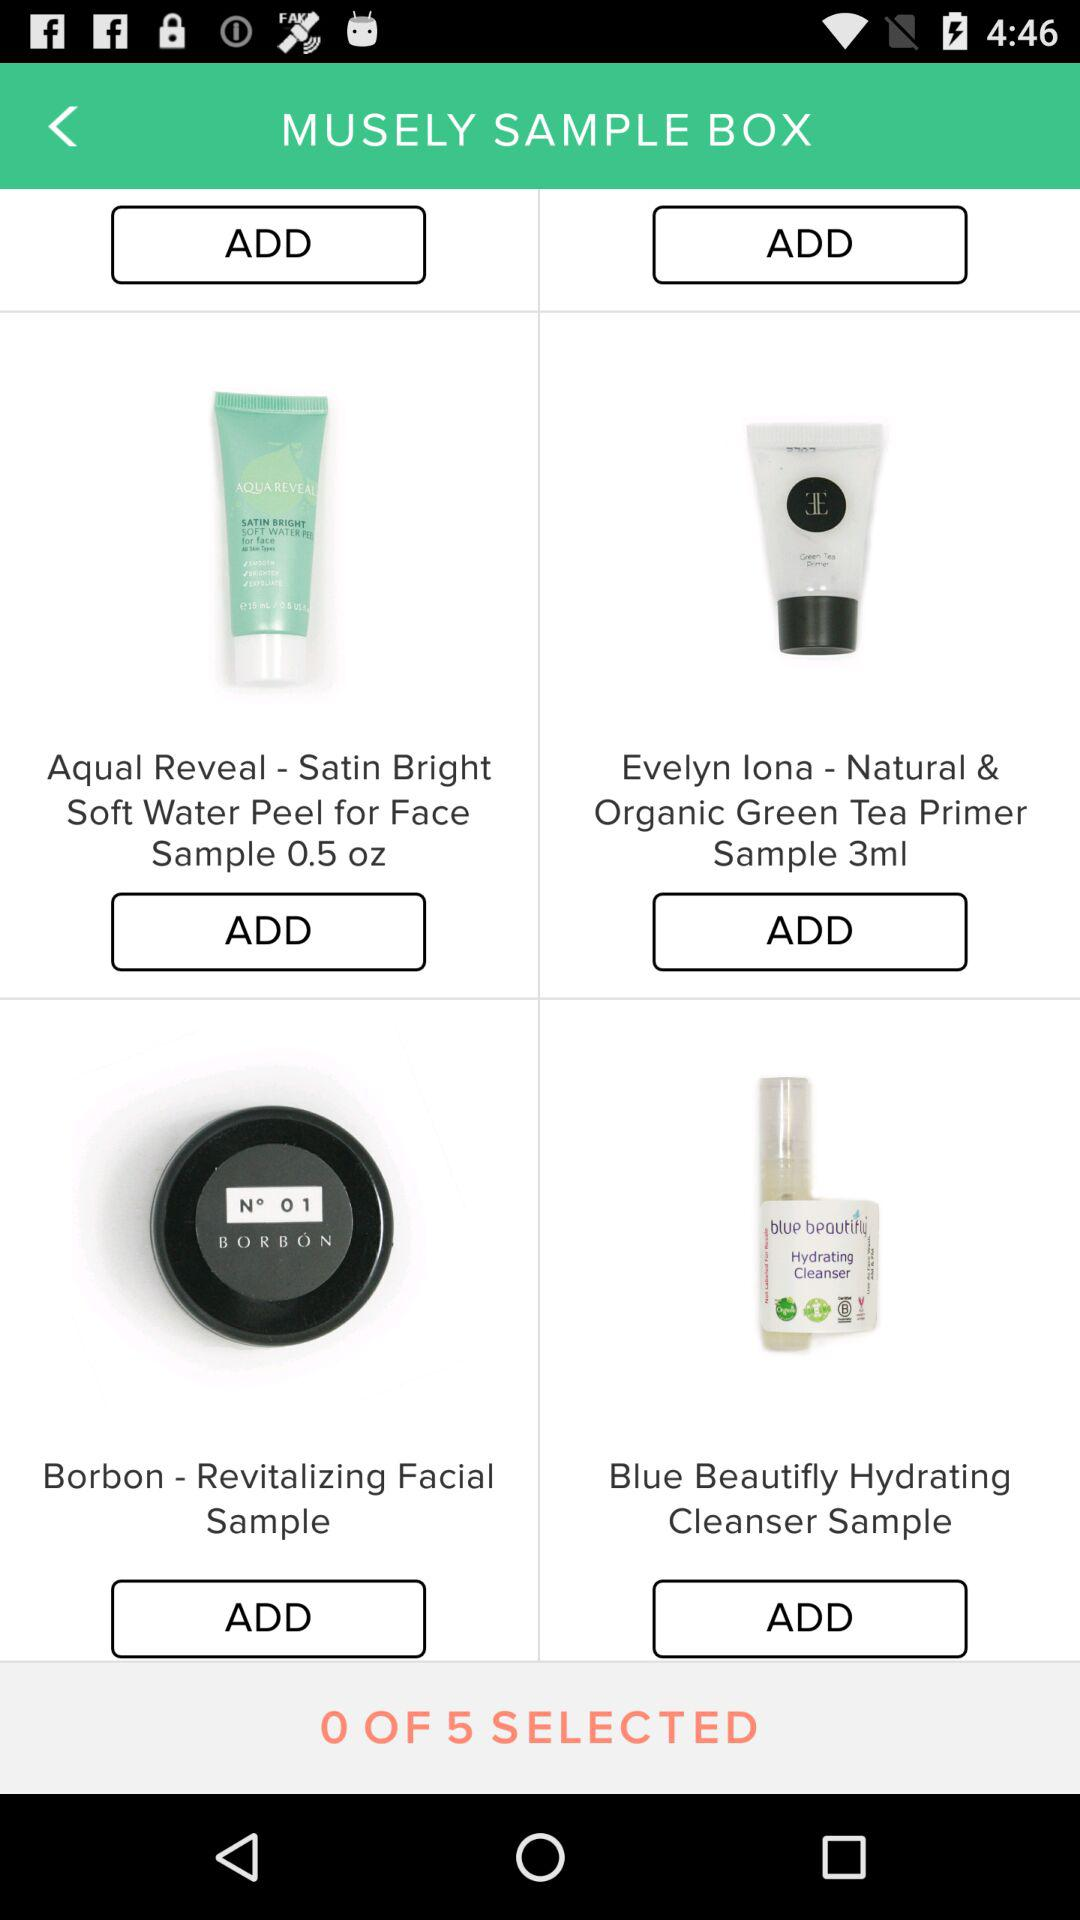What number of items can be selected? The number of items that can be selected is 5. 